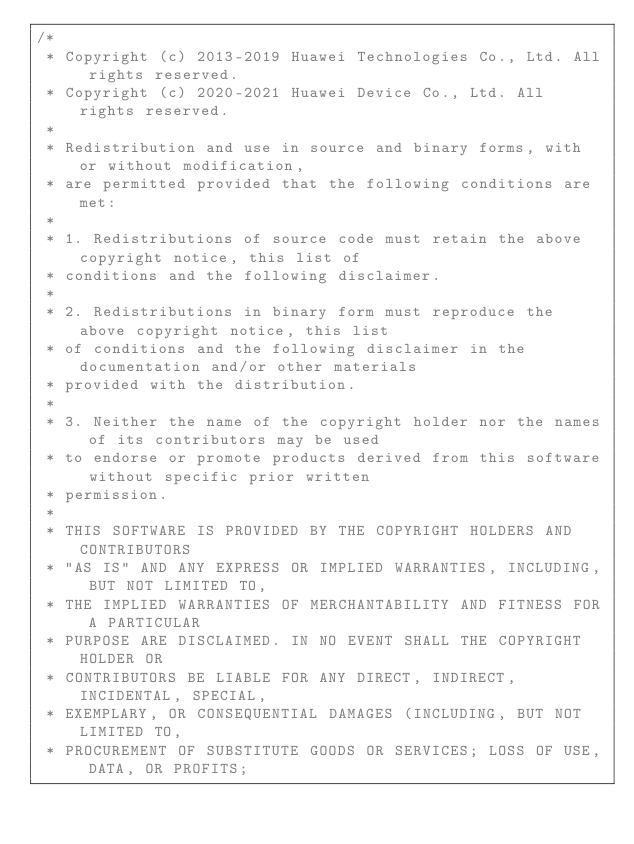Convert code to text. <code><loc_0><loc_0><loc_500><loc_500><_C++_>/*
 * Copyright (c) 2013-2019 Huawei Technologies Co., Ltd. All rights reserved.
 * Copyright (c) 2020-2021 Huawei Device Co., Ltd. All rights reserved.
 *
 * Redistribution and use in source and binary forms, with or without modification,
 * are permitted provided that the following conditions are met:
 *
 * 1. Redistributions of source code must retain the above copyright notice, this list of
 * conditions and the following disclaimer.
 *
 * 2. Redistributions in binary form must reproduce the above copyright notice, this list
 * of conditions and the following disclaimer in the documentation and/or other materials
 * provided with the distribution.
 *
 * 3. Neither the name of the copyright holder nor the names of its contributors may be used
 * to endorse or promote products derived from this software without specific prior written
 * permission.
 *
 * THIS SOFTWARE IS PROVIDED BY THE COPYRIGHT HOLDERS AND CONTRIBUTORS
 * "AS IS" AND ANY EXPRESS OR IMPLIED WARRANTIES, INCLUDING, BUT NOT LIMITED TO,
 * THE IMPLIED WARRANTIES OF MERCHANTABILITY AND FITNESS FOR A PARTICULAR
 * PURPOSE ARE DISCLAIMED. IN NO EVENT SHALL THE COPYRIGHT HOLDER OR
 * CONTRIBUTORS BE LIABLE FOR ANY DIRECT, INDIRECT, INCIDENTAL, SPECIAL,
 * EXEMPLARY, OR CONSEQUENTIAL DAMAGES (INCLUDING, BUT NOT LIMITED TO,
 * PROCUREMENT OF SUBSTITUTE GOODS OR SERVICES; LOSS OF USE, DATA, OR PROFITS;</code> 